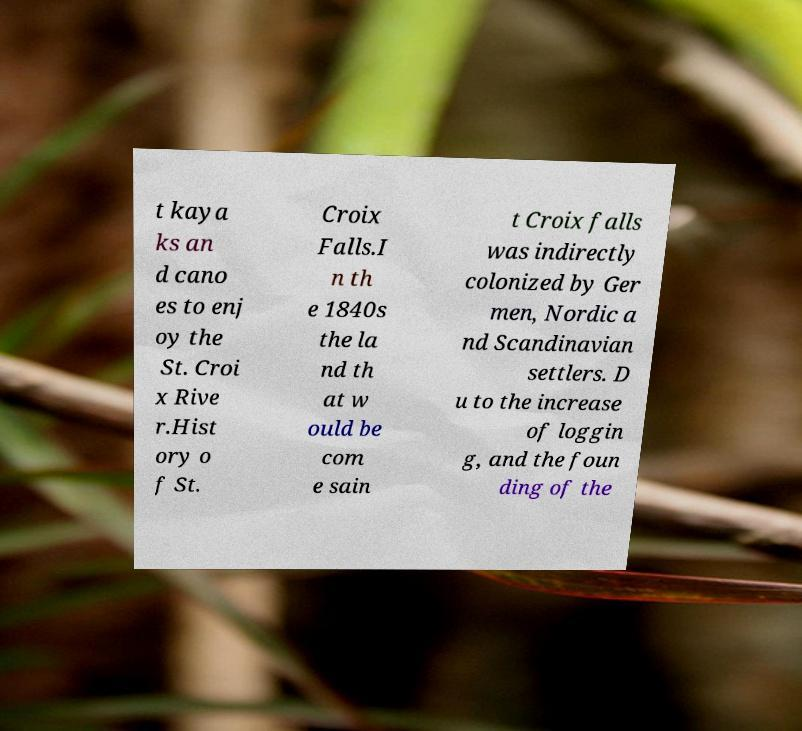Could you assist in decoding the text presented in this image and type it out clearly? t kaya ks an d cano es to enj oy the St. Croi x Rive r.Hist ory o f St. Croix Falls.I n th e 1840s the la nd th at w ould be com e sain t Croix falls was indirectly colonized by Ger men, Nordic a nd Scandinavian settlers. D u to the increase of loggin g, and the foun ding of the 